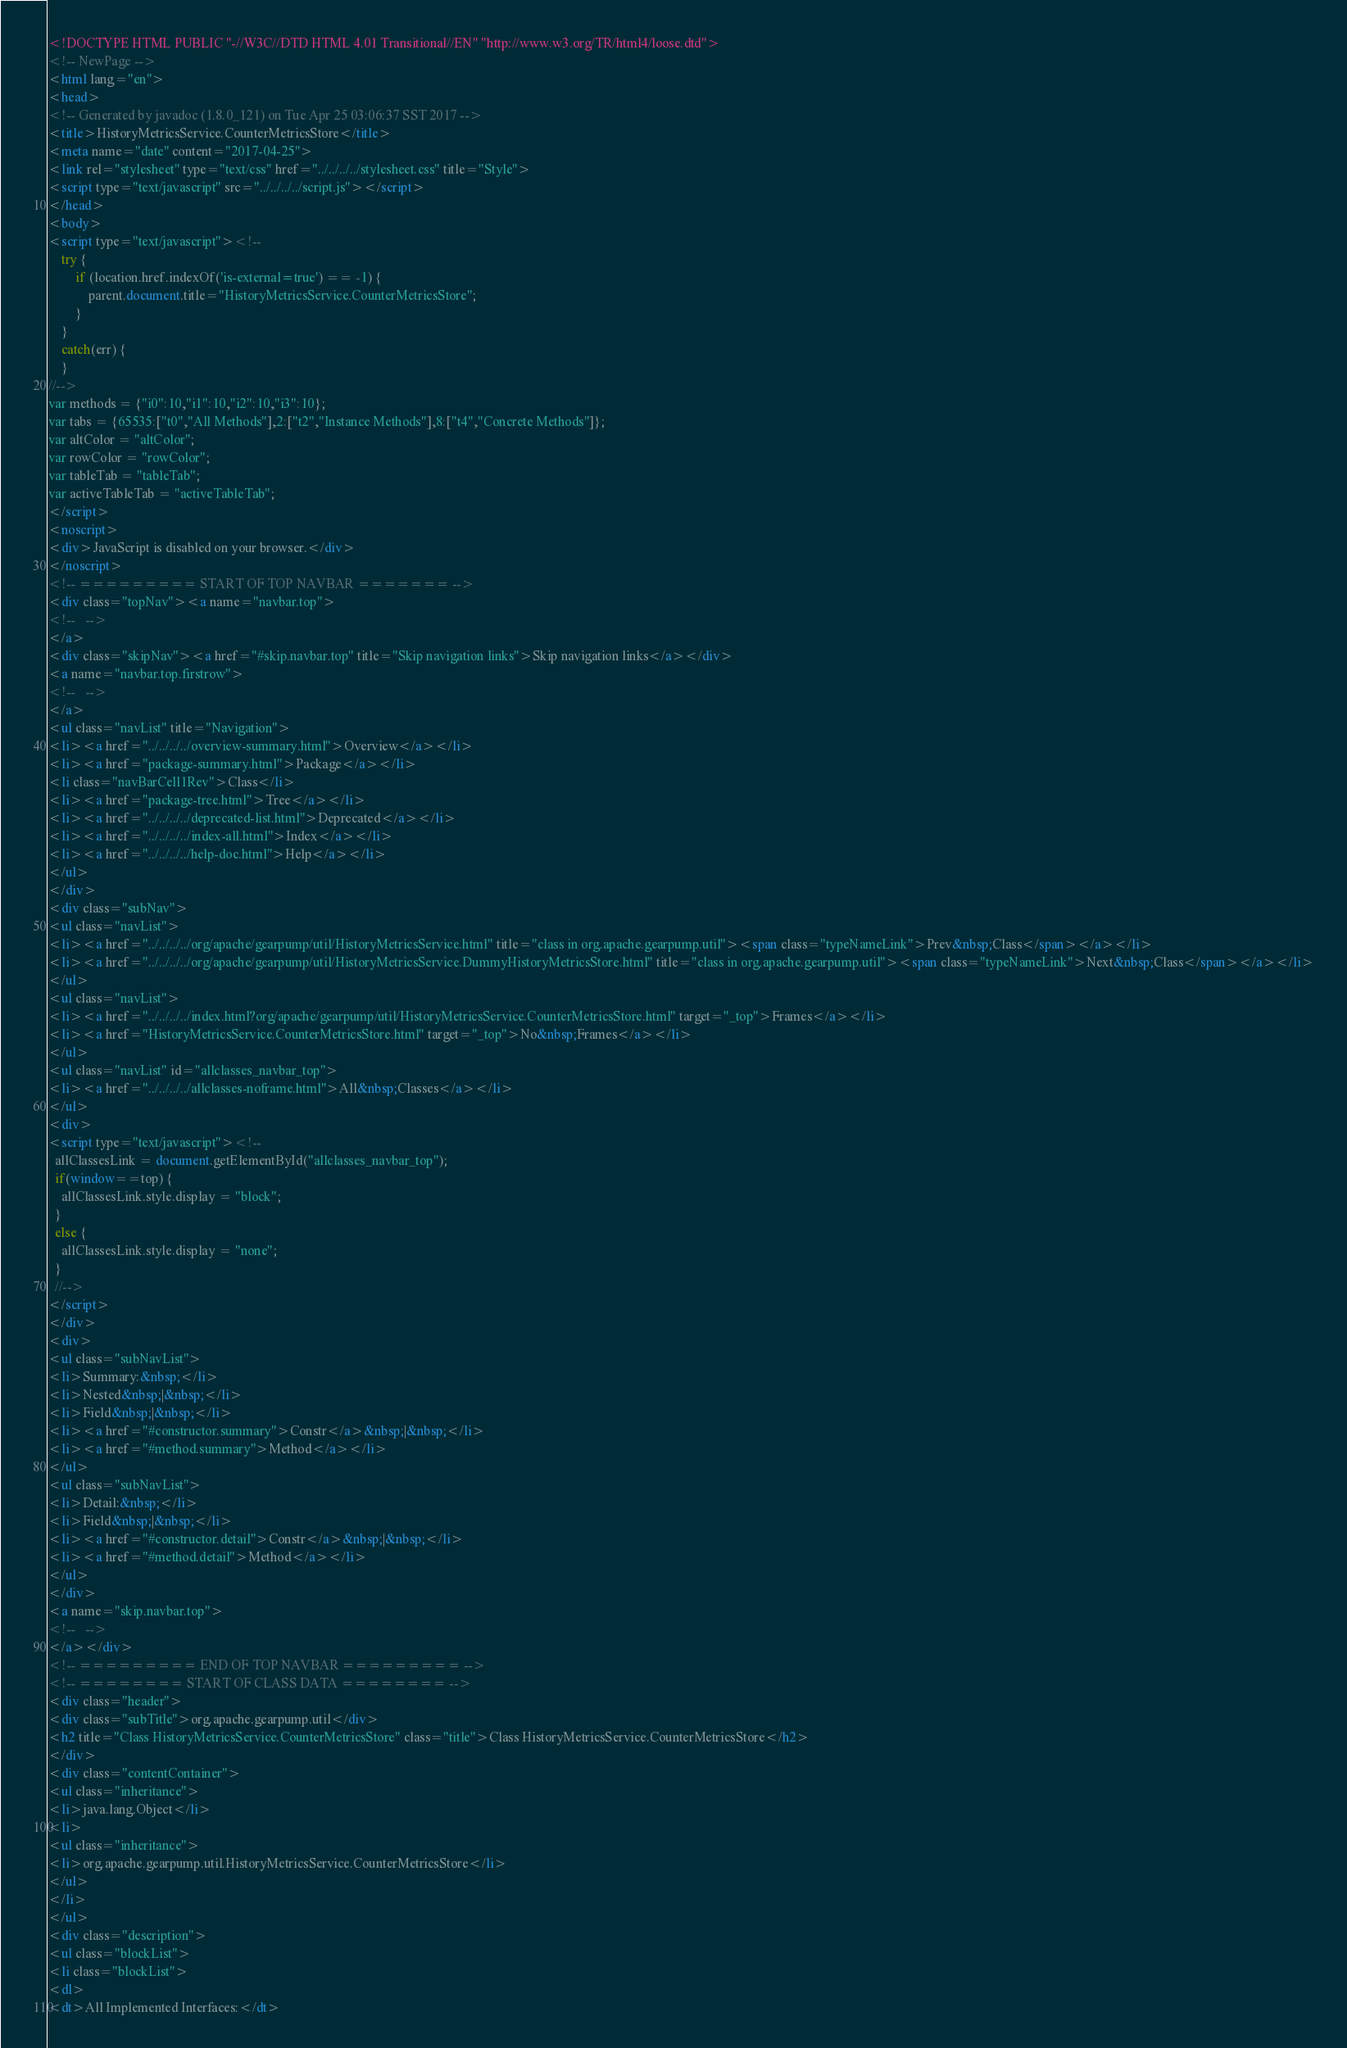Convert code to text. <code><loc_0><loc_0><loc_500><loc_500><_HTML_><!DOCTYPE HTML PUBLIC "-//W3C//DTD HTML 4.01 Transitional//EN" "http://www.w3.org/TR/html4/loose.dtd">
<!-- NewPage -->
<html lang="en">
<head>
<!-- Generated by javadoc (1.8.0_121) on Tue Apr 25 03:06:37 SST 2017 -->
<title>HistoryMetricsService.CounterMetricsStore</title>
<meta name="date" content="2017-04-25">
<link rel="stylesheet" type="text/css" href="../../../../stylesheet.css" title="Style">
<script type="text/javascript" src="../../../../script.js"></script>
</head>
<body>
<script type="text/javascript"><!--
    try {
        if (location.href.indexOf('is-external=true') == -1) {
            parent.document.title="HistoryMetricsService.CounterMetricsStore";
        }
    }
    catch(err) {
    }
//-->
var methods = {"i0":10,"i1":10,"i2":10,"i3":10};
var tabs = {65535:["t0","All Methods"],2:["t2","Instance Methods"],8:["t4","Concrete Methods"]};
var altColor = "altColor";
var rowColor = "rowColor";
var tableTab = "tableTab";
var activeTableTab = "activeTableTab";
</script>
<noscript>
<div>JavaScript is disabled on your browser.</div>
</noscript>
<!-- ========= START OF TOP NAVBAR ======= -->
<div class="topNav"><a name="navbar.top">
<!--   -->
</a>
<div class="skipNav"><a href="#skip.navbar.top" title="Skip navigation links">Skip navigation links</a></div>
<a name="navbar.top.firstrow">
<!--   -->
</a>
<ul class="navList" title="Navigation">
<li><a href="../../../../overview-summary.html">Overview</a></li>
<li><a href="package-summary.html">Package</a></li>
<li class="navBarCell1Rev">Class</li>
<li><a href="package-tree.html">Tree</a></li>
<li><a href="../../../../deprecated-list.html">Deprecated</a></li>
<li><a href="../../../../index-all.html">Index</a></li>
<li><a href="../../../../help-doc.html">Help</a></li>
</ul>
</div>
<div class="subNav">
<ul class="navList">
<li><a href="../../../../org/apache/gearpump/util/HistoryMetricsService.html" title="class in org.apache.gearpump.util"><span class="typeNameLink">Prev&nbsp;Class</span></a></li>
<li><a href="../../../../org/apache/gearpump/util/HistoryMetricsService.DummyHistoryMetricsStore.html" title="class in org.apache.gearpump.util"><span class="typeNameLink">Next&nbsp;Class</span></a></li>
</ul>
<ul class="navList">
<li><a href="../../../../index.html?org/apache/gearpump/util/HistoryMetricsService.CounterMetricsStore.html" target="_top">Frames</a></li>
<li><a href="HistoryMetricsService.CounterMetricsStore.html" target="_top">No&nbsp;Frames</a></li>
</ul>
<ul class="navList" id="allclasses_navbar_top">
<li><a href="../../../../allclasses-noframe.html">All&nbsp;Classes</a></li>
</ul>
<div>
<script type="text/javascript"><!--
  allClassesLink = document.getElementById("allclasses_navbar_top");
  if(window==top) {
    allClassesLink.style.display = "block";
  }
  else {
    allClassesLink.style.display = "none";
  }
  //-->
</script>
</div>
<div>
<ul class="subNavList">
<li>Summary:&nbsp;</li>
<li>Nested&nbsp;|&nbsp;</li>
<li>Field&nbsp;|&nbsp;</li>
<li><a href="#constructor.summary">Constr</a>&nbsp;|&nbsp;</li>
<li><a href="#method.summary">Method</a></li>
</ul>
<ul class="subNavList">
<li>Detail:&nbsp;</li>
<li>Field&nbsp;|&nbsp;</li>
<li><a href="#constructor.detail">Constr</a>&nbsp;|&nbsp;</li>
<li><a href="#method.detail">Method</a></li>
</ul>
</div>
<a name="skip.navbar.top">
<!--   -->
</a></div>
<!-- ========= END OF TOP NAVBAR ========= -->
<!-- ======== START OF CLASS DATA ======== -->
<div class="header">
<div class="subTitle">org.apache.gearpump.util</div>
<h2 title="Class HistoryMetricsService.CounterMetricsStore" class="title">Class HistoryMetricsService.CounterMetricsStore</h2>
</div>
<div class="contentContainer">
<ul class="inheritance">
<li>java.lang.Object</li>
<li>
<ul class="inheritance">
<li>org.apache.gearpump.util.HistoryMetricsService.CounterMetricsStore</li>
</ul>
</li>
</ul>
<div class="description">
<ul class="blockList">
<li class="blockList">
<dl>
<dt>All Implemented Interfaces:</dt></code> 